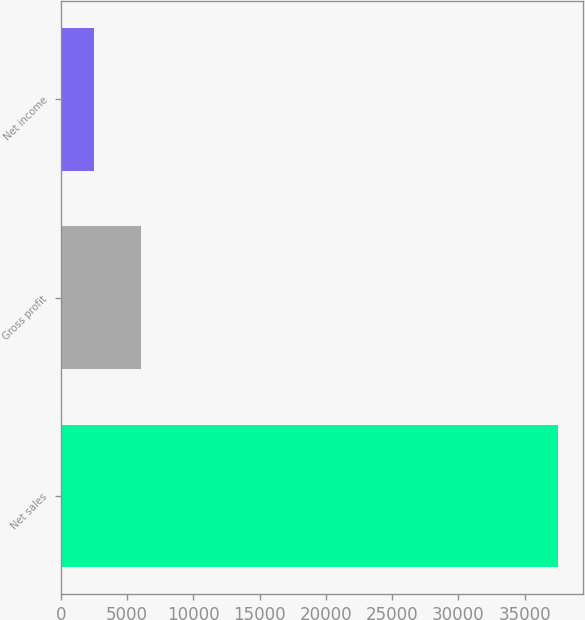Convert chart to OTSL. <chart><loc_0><loc_0><loc_500><loc_500><bar_chart><fcel>Net sales<fcel>Gross profit<fcel>Net income<nl><fcel>37542<fcel>6006.9<fcel>2503<nl></chart> 